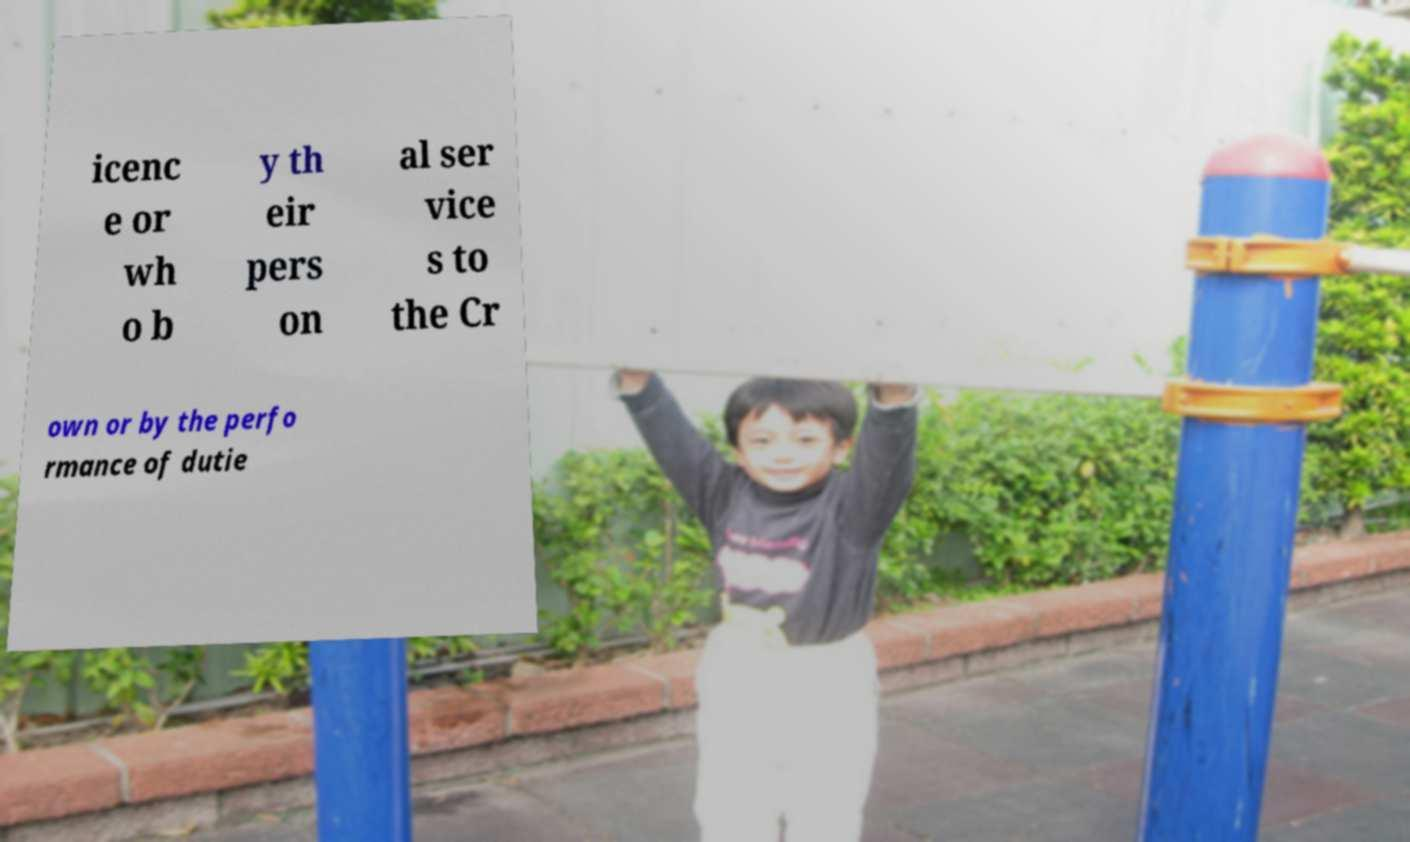Could you assist in decoding the text presented in this image and type it out clearly? icenc e or wh o b y th eir pers on al ser vice s to the Cr own or by the perfo rmance of dutie 